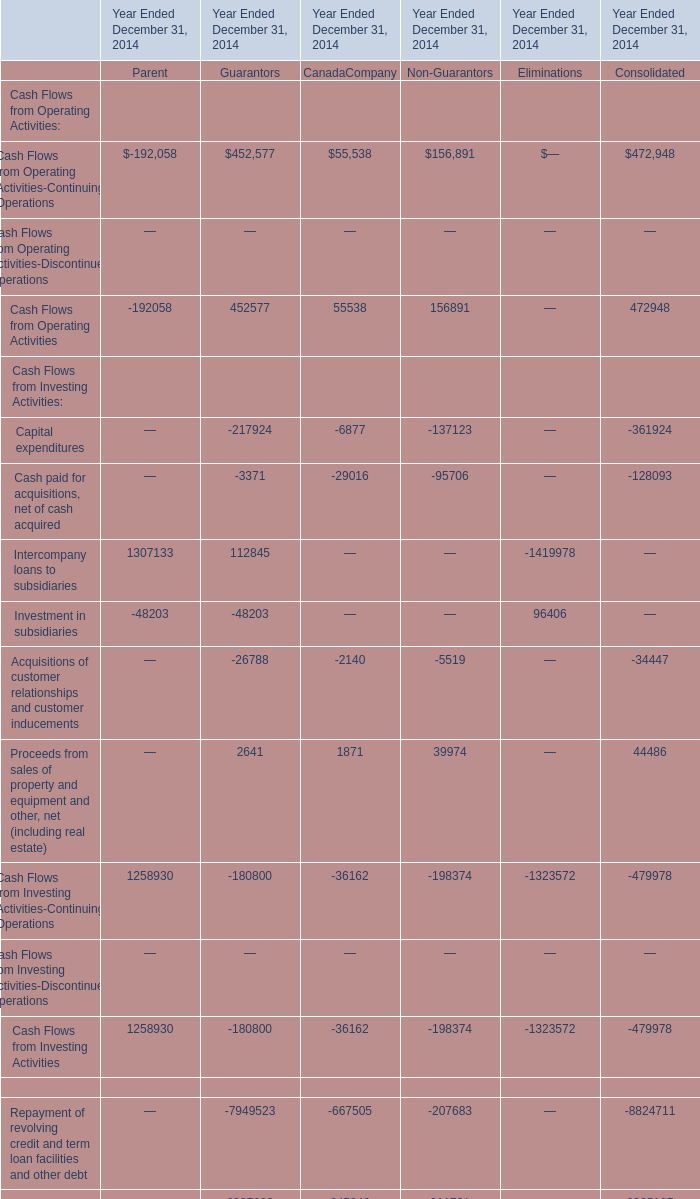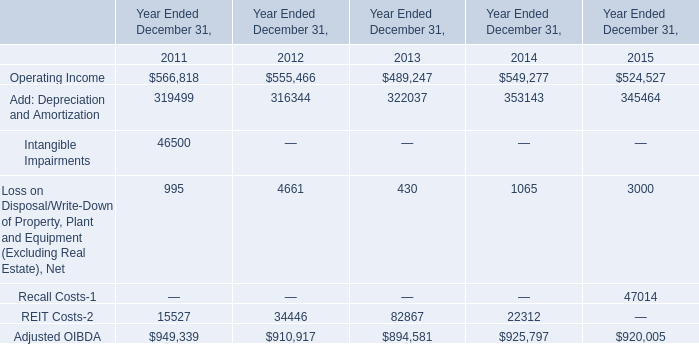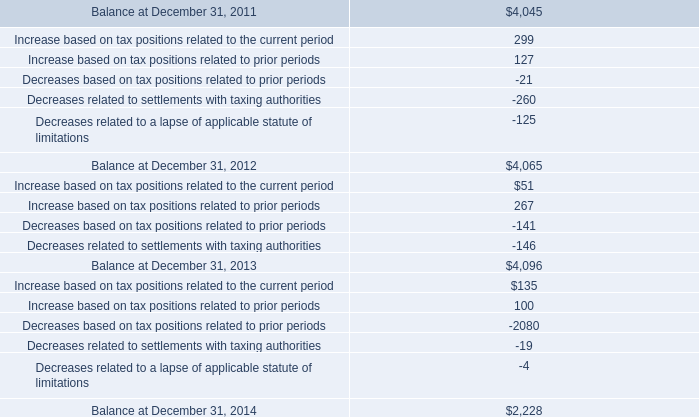What is the ratio of Equity contribution from parent of Guarantors in Table 0 to the REIT Costs-2 in Table 1 in 2014? 
Computations: (48203 / 22312)
Answer: 2.16041. 